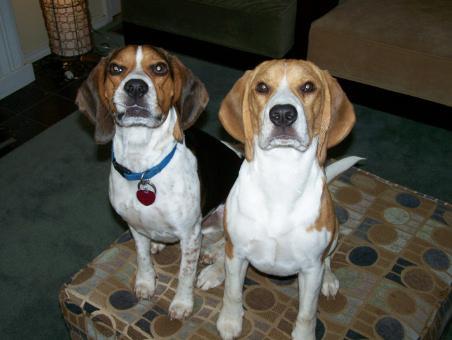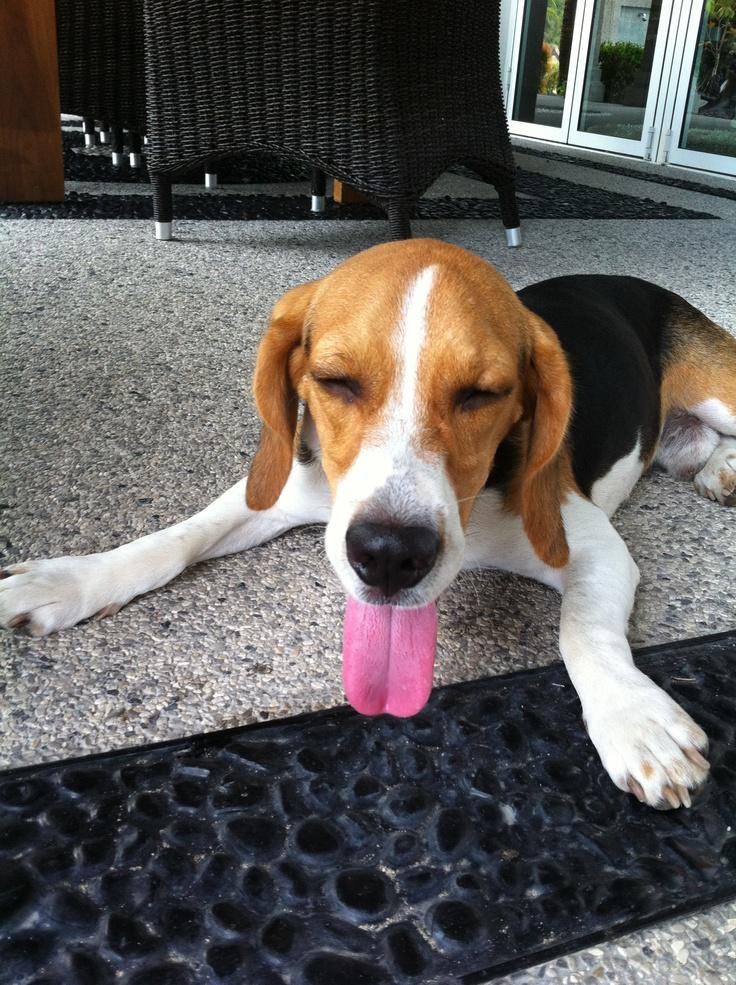The first image is the image on the left, the second image is the image on the right. For the images shown, is this caption "One image contains one dog, which wears a blue collar, and the other image features a dog wearing a costume that includes a hat and something around its neck." true? Answer yes or no. No. The first image is the image on the left, the second image is the image on the right. For the images shown, is this caption "A dog in one of the images is wearing something on top of its head." true? Answer yes or no. No. 